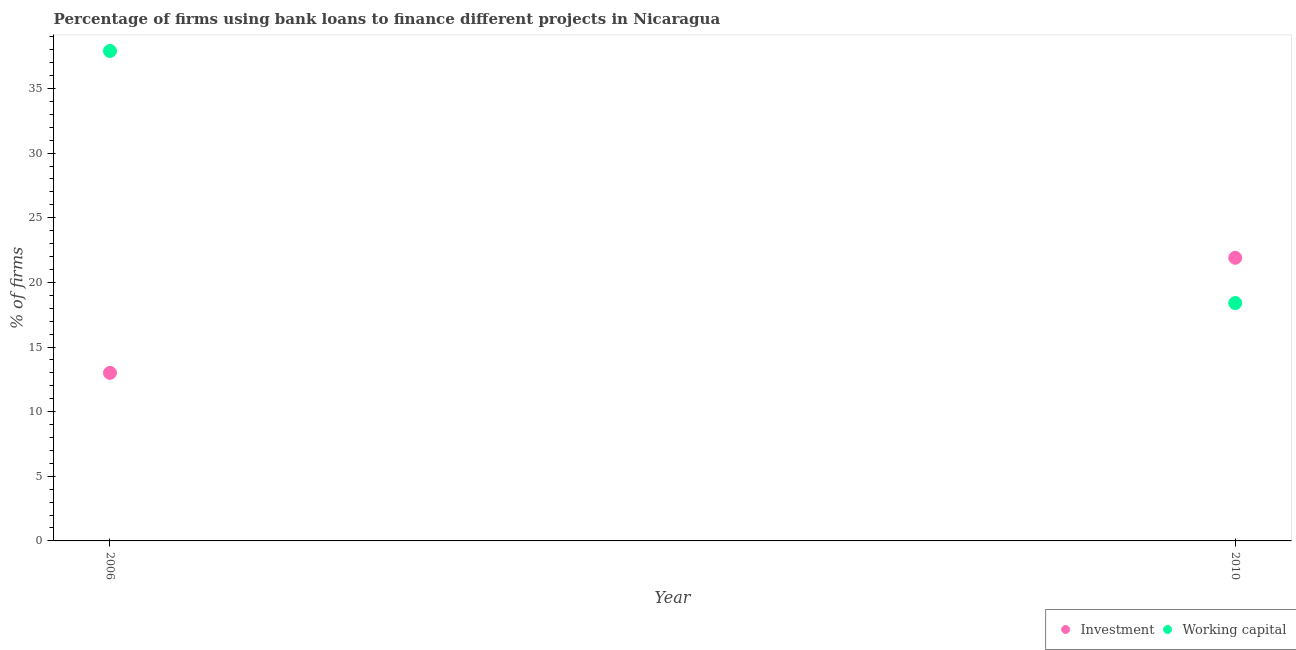How many different coloured dotlines are there?
Your answer should be compact. 2. Is the number of dotlines equal to the number of legend labels?
Your answer should be compact. Yes. Across all years, what is the maximum percentage of firms using banks to finance working capital?
Ensure brevity in your answer.  37.9. Across all years, what is the minimum percentage of firms using banks to finance working capital?
Give a very brief answer. 18.4. In which year was the percentage of firms using banks to finance investment maximum?
Give a very brief answer. 2010. In which year was the percentage of firms using banks to finance investment minimum?
Provide a succinct answer. 2006. What is the total percentage of firms using banks to finance investment in the graph?
Your response must be concise. 34.9. What is the difference between the percentage of firms using banks to finance working capital in 2006 and that in 2010?
Provide a short and direct response. 19.5. What is the difference between the percentage of firms using banks to finance working capital in 2010 and the percentage of firms using banks to finance investment in 2006?
Give a very brief answer. 5.4. What is the average percentage of firms using banks to finance working capital per year?
Offer a very short reply. 28.15. In the year 2010, what is the difference between the percentage of firms using banks to finance working capital and percentage of firms using banks to finance investment?
Your response must be concise. -3.5. What is the ratio of the percentage of firms using banks to finance working capital in 2006 to that in 2010?
Ensure brevity in your answer.  2.06. Is the percentage of firms using banks to finance working capital strictly greater than the percentage of firms using banks to finance investment over the years?
Your response must be concise. No. How many dotlines are there?
Provide a succinct answer. 2. How many years are there in the graph?
Give a very brief answer. 2. Does the graph contain grids?
Ensure brevity in your answer.  No. What is the title of the graph?
Keep it short and to the point. Percentage of firms using bank loans to finance different projects in Nicaragua. What is the label or title of the Y-axis?
Give a very brief answer. % of firms. What is the % of firms of Investment in 2006?
Keep it short and to the point. 13. What is the % of firms in Working capital in 2006?
Provide a succinct answer. 37.9. What is the % of firms in Investment in 2010?
Your response must be concise. 21.9. Across all years, what is the maximum % of firms in Investment?
Offer a terse response. 21.9. Across all years, what is the maximum % of firms of Working capital?
Provide a short and direct response. 37.9. Across all years, what is the minimum % of firms in Working capital?
Keep it short and to the point. 18.4. What is the total % of firms in Investment in the graph?
Your response must be concise. 34.9. What is the total % of firms in Working capital in the graph?
Make the answer very short. 56.3. What is the difference between the % of firms of Investment in 2006 and that in 2010?
Keep it short and to the point. -8.9. What is the difference between the % of firms of Working capital in 2006 and that in 2010?
Make the answer very short. 19.5. What is the average % of firms in Investment per year?
Give a very brief answer. 17.45. What is the average % of firms of Working capital per year?
Your answer should be very brief. 28.15. In the year 2006, what is the difference between the % of firms in Investment and % of firms in Working capital?
Give a very brief answer. -24.9. In the year 2010, what is the difference between the % of firms in Investment and % of firms in Working capital?
Keep it short and to the point. 3.5. What is the ratio of the % of firms of Investment in 2006 to that in 2010?
Offer a terse response. 0.59. What is the ratio of the % of firms in Working capital in 2006 to that in 2010?
Provide a succinct answer. 2.06. What is the difference between the highest and the second highest % of firms of Investment?
Provide a short and direct response. 8.9. What is the difference between the highest and the second highest % of firms of Working capital?
Make the answer very short. 19.5. What is the difference between the highest and the lowest % of firms in Investment?
Your answer should be compact. 8.9. What is the difference between the highest and the lowest % of firms in Working capital?
Your answer should be very brief. 19.5. 